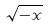<formula> <loc_0><loc_0><loc_500><loc_500>\sqrt { - x }</formula> 